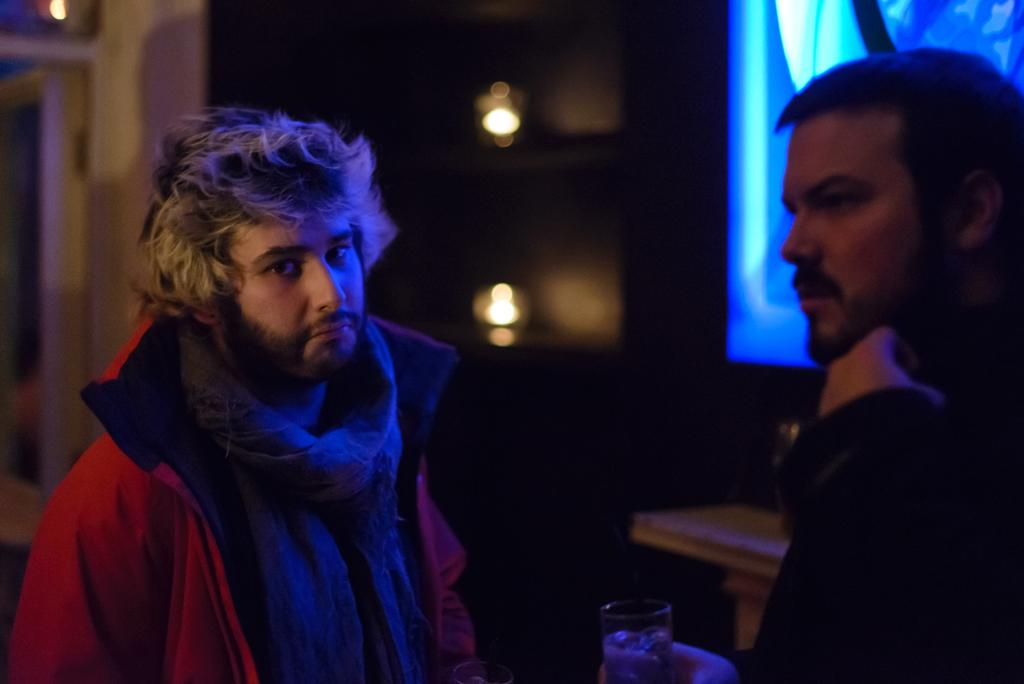How many men are present in the image? There are two men in the image. What are the men wearing in the image? The men are wearing coats in the image. Can you describe the background of the image? There are two lights in the background of the image. What type of government is depicted in the image? There is no depiction of a government in the image; it features two men wearing coats. What shape is the home in the image? There is no home present in the image. 